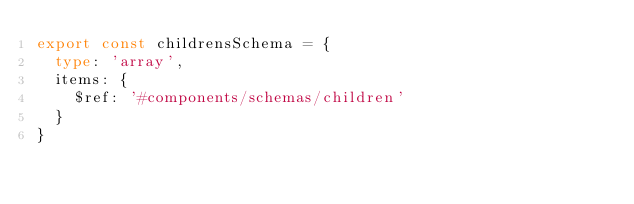Convert code to text. <code><loc_0><loc_0><loc_500><loc_500><_TypeScript_>export const childrensSchema = {
  type: 'array',
  items: {
    $ref: '#components/schemas/children'
  }
}
</code> 